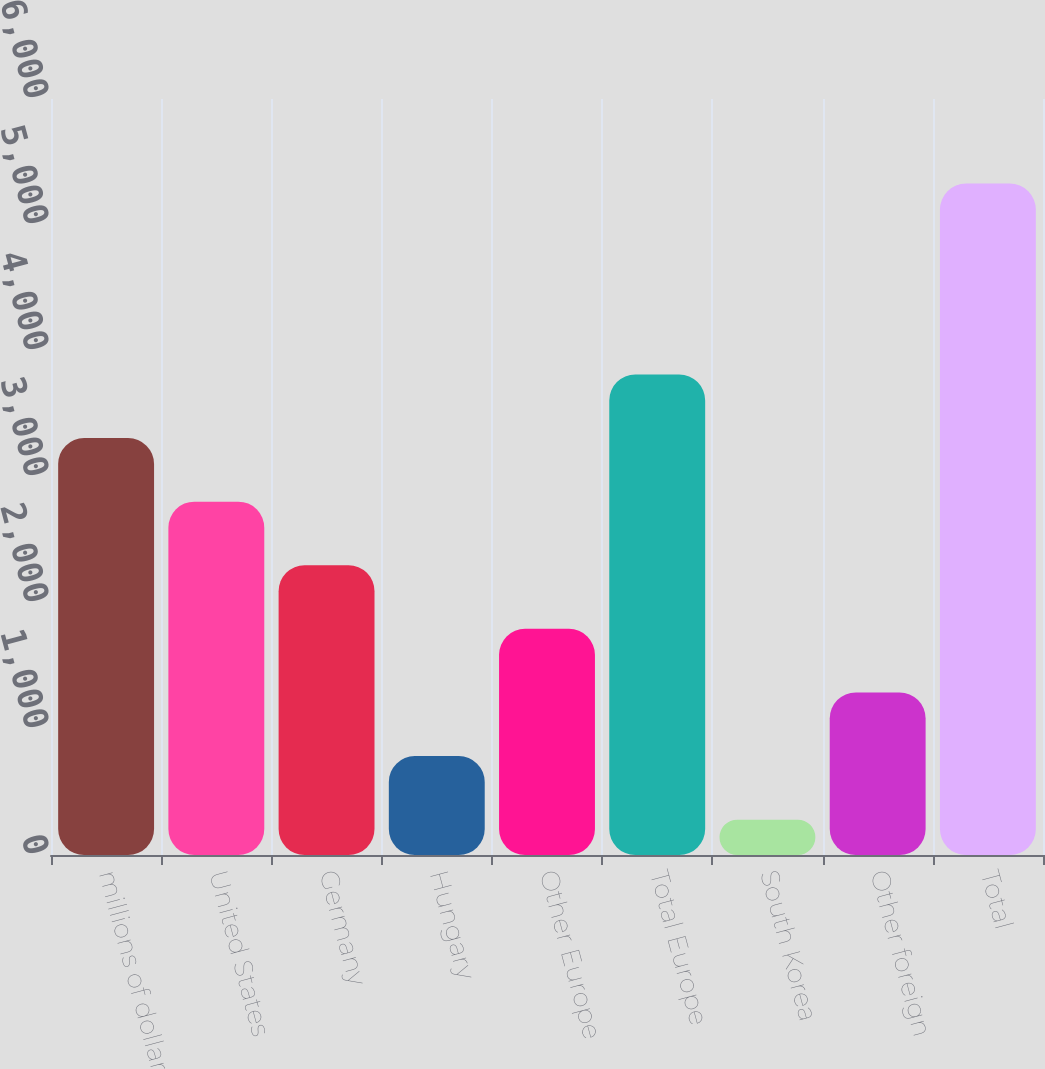<chart> <loc_0><loc_0><loc_500><loc_500><bar_chart><fcel>millions of dollars<fcel>United States<fcel>Germany<fcel>Hungary<fcel>Other Europe<fcel>Total Europe<fcel>South Korea<fcel>Other foreign<fcel>Total<nl><fcel>3309.28<fcel>2804.45<fcel>2299.62<fcel>785.13<fcel>1794.79<fcel>3814.11<fcel>280.3<fcel>1289.96<fcel>5328.6<nl></chart> 